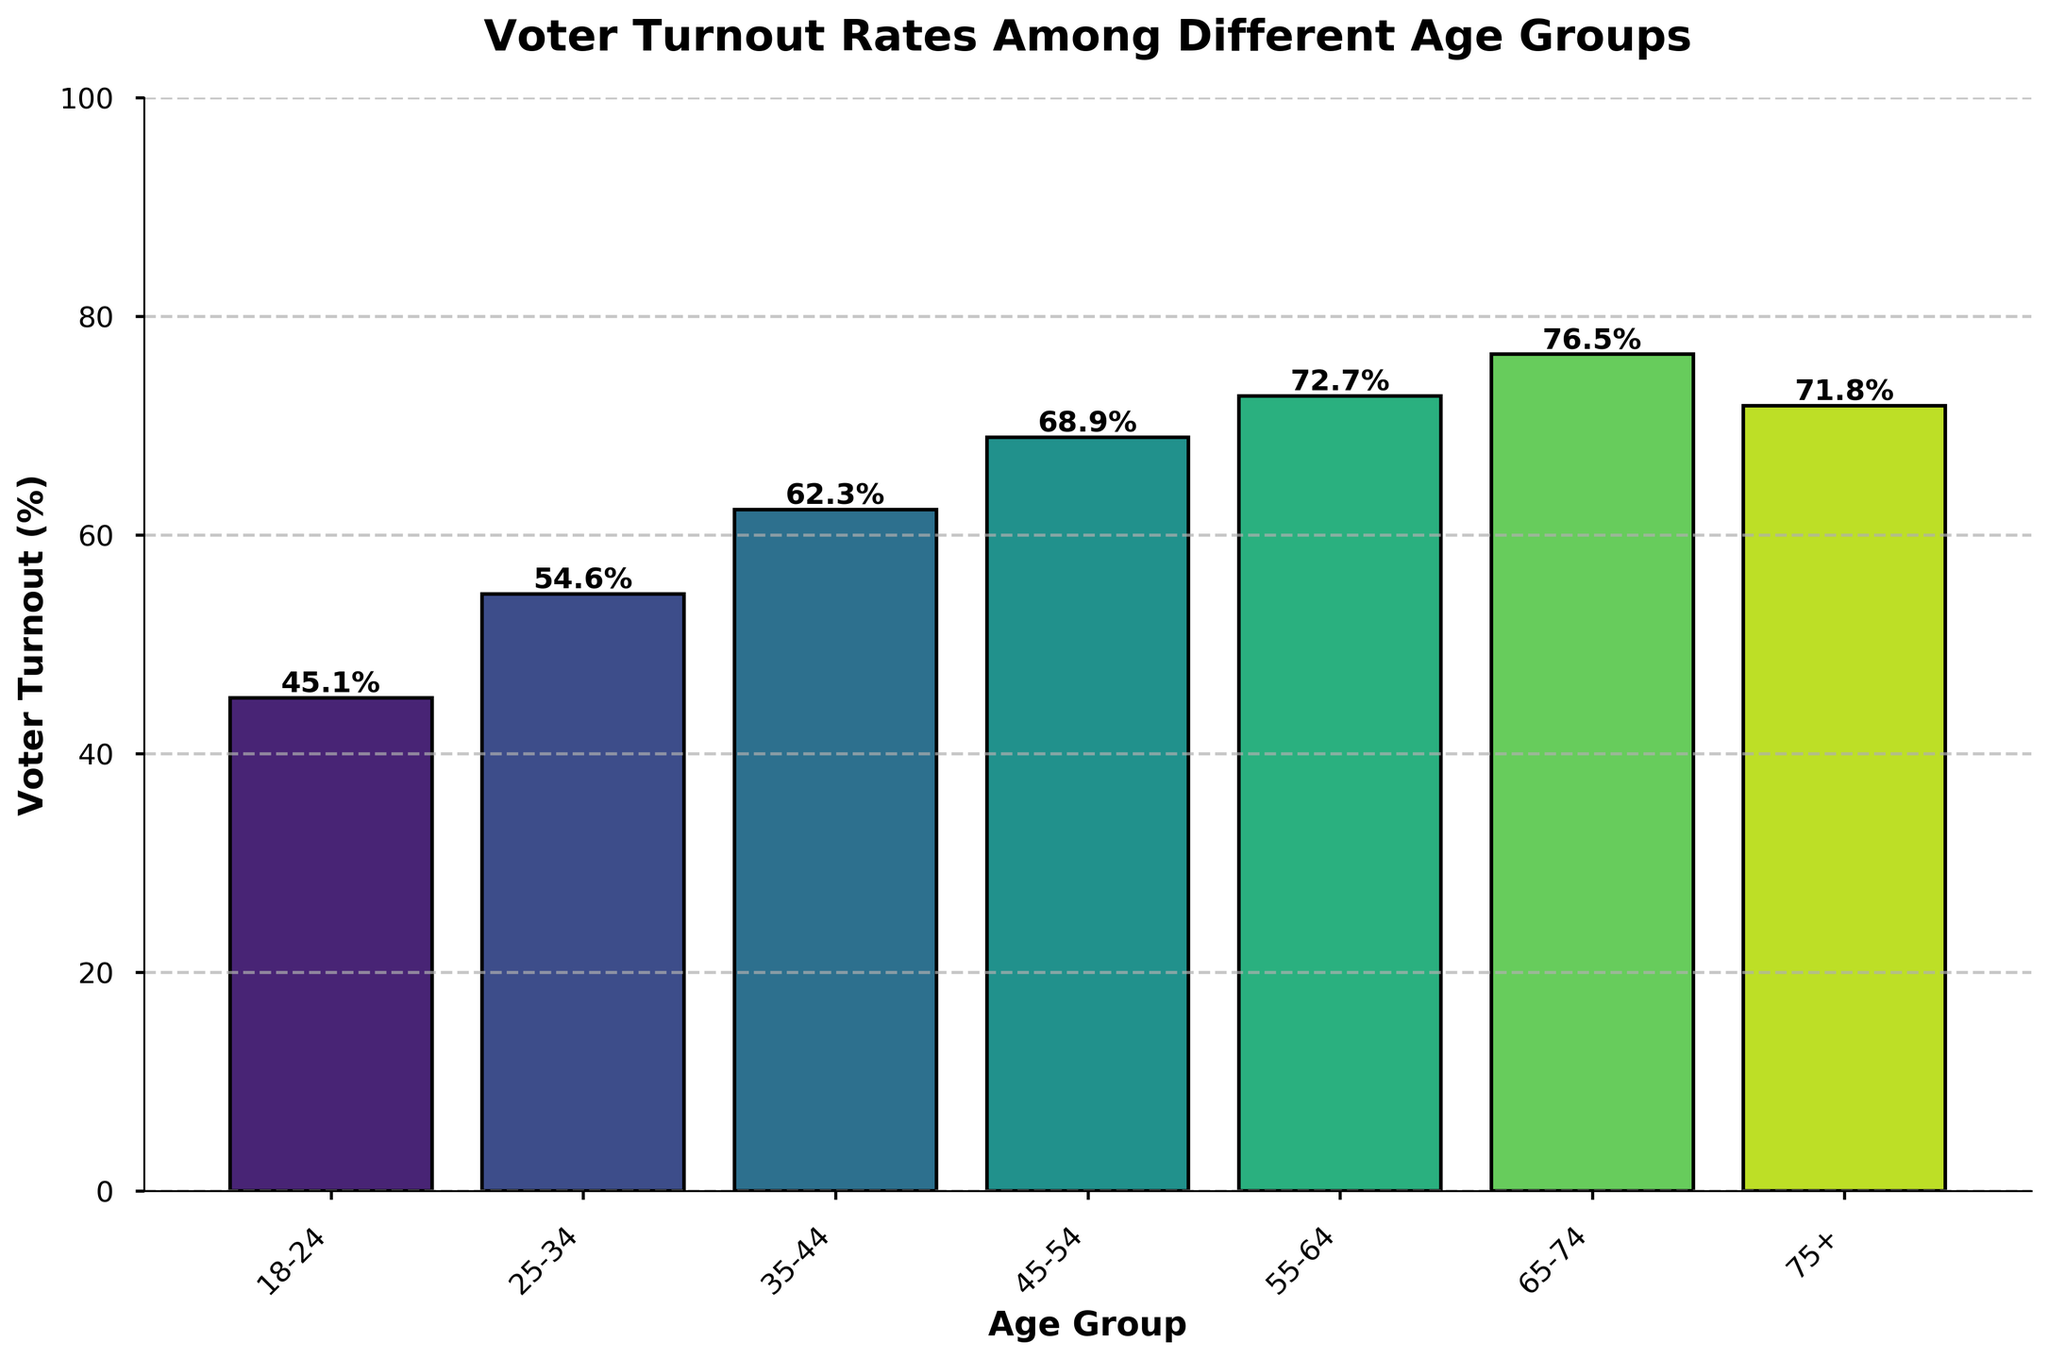What is the voter turnout rate for the 18-24 age group? The 18-24 age group has a voter turnout rate of 45.1%, which can be directly observed from the height of the bar corresponding to this age group.
Answer: 45.1% Which age group has the highest voter turnout rate? By comparing the heights of all bars, the 65-74 age group has the tallest bar, indicating the highest voter turnout rate at 76.5%.
Answer: 65-74 What is the difference in voter turnout rates between the 35-44 and 55-64 age groups? The voter turnout rate for the 35-44 age group is 62.3%, and for the 55-64 age group, it is 72.7%. The difference is 72.7% - 62.3% = 10.4%.
Answer: 10.4% Is there a noticeable trend in voter turnout rates as age increases? The voter turnout rates generally increase as the age groups go from 18-24 to 65-74. After that, the rate slightly decreases for the 75+ age group. This trend is visually evident from the increasing bar heights up to the 65-74 group and a slight decrease afterwards.
Answer: Yes Which age group has a voter turnout rate closest to 70%? The 55-64 age group has a voter turnout rate of 72.7%, and the 75+ age group has 71.8%. The 75+ age group is closer to 70% than the 55-64 age group.
Answer: 75+ What is the average voter turnout rate across all age groups? Sum the voter turnout rates: 45.1 + 54.6 + 62.3 + 68.9 + 72.7 + 76.5 + 71.8 = 452.9. Divide by the number of age groups: 452.9 / 7 ≈ 64.7%.
Answer: 64.7% What is the ratio of the voter turnout rate of the 45-54 age group to the 18-24 age group? The voter turnout rate for the 45-54 age group is 68.9% and for the 18-24 age group is 45.1%. The ratio is 68.9% / 45.1% ≈ 1.53.
Answer: 1.53 How many age groups have a voter turnout rate above 60%? The age groups with voter turnout rates above 60% are 35-44, 45-54, 55-64, 65-74, and 75+. There are 5 such age groups.
Answer: 5 If you combine the voter turnout rates of the 65-74 and 75+ age groups, what is their total? The voter turnout rate for the 65-74 age group is 76.5% and for the 75+ age group is 71.8%. Their total is 76.5 + 71.8 = 148.3%.
Answer: 148.3% What is the median voter turnout rate among the age groups? The voter turnout rates in ascending order are 45.1%, 54.6%, 62.3%, 68.9%, 71.8%, 72.7%, and 76.5%. The median value, the middle value in this ordered list, is 68.9%.
Answer: 68.9% 